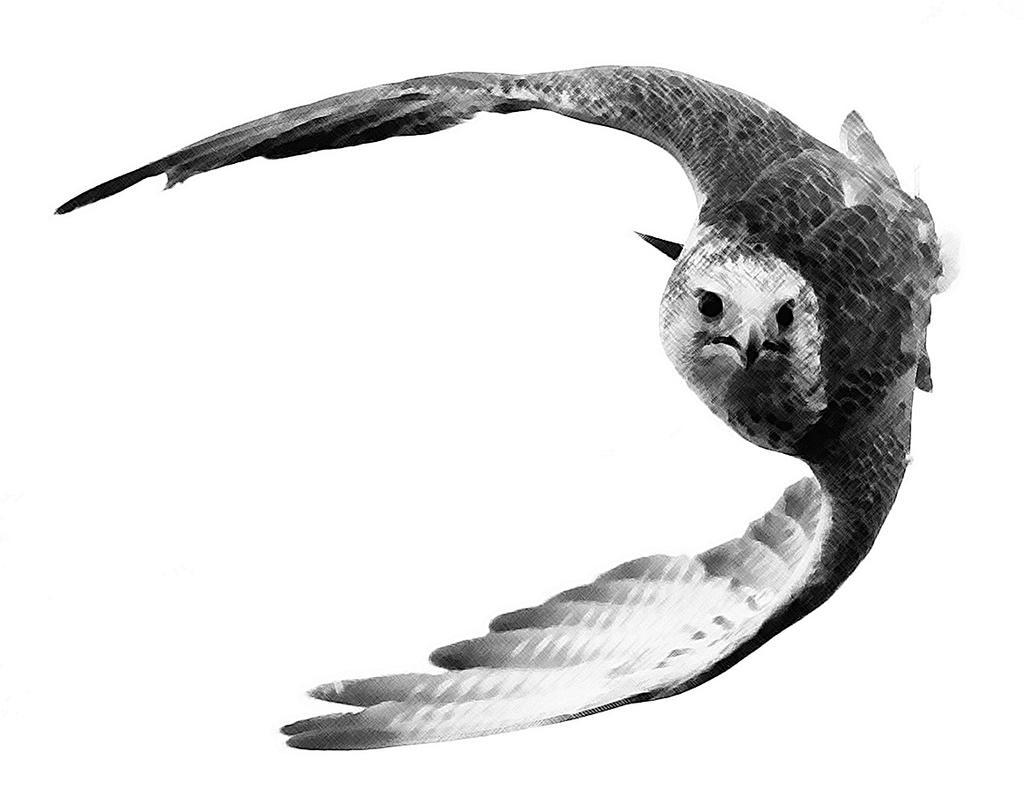Can you describe this image briefly? In the picture I can see an eagle. The background of the image is white in color. This picture is black and white in color. 